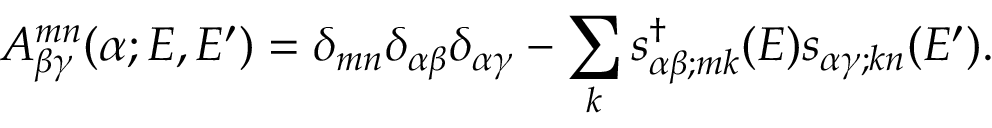<formula> <loc_0><loc_0><loc_500><loc_500>A _ { \beta \gamma } ^ { m n } ( \alpha ; E , E ^ { \prime } ) = \delta _ { m n } \delta _ { \alpha \beta } \delta _ { \alpha \gamma } - \sum _ { k } s _ { \alpha \beta ; m k } ^ { \dagger } ( E ) s _ { \alpha \gamma ; k n } ( E ^ { \prime } ) .</formula> 